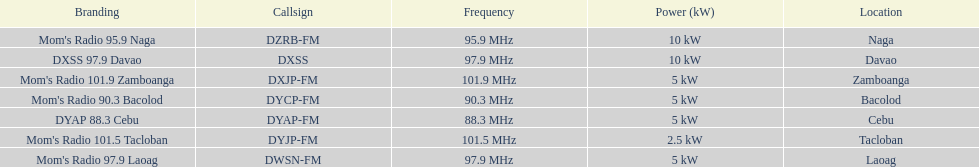What is the number of these stations broadcasting at a frequency of greater than 100 mhz? 2. 